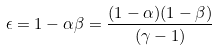<formula> <loc_0><loc_0><loc_500><loc_500>\epsilon = 1 - \alpha \beta = \frac { ( 1 - \alpha ) ( 1 - \beta ) } { ( \gamma - 1 ) }</formula> 